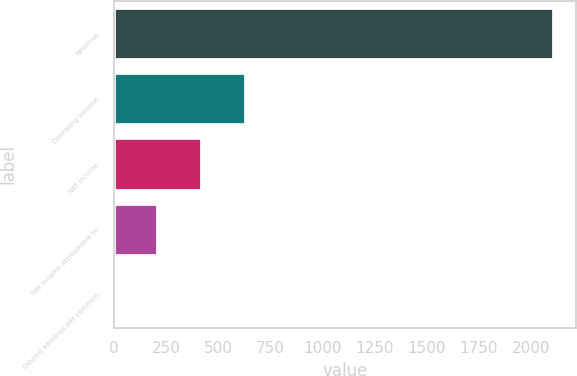<chart> <loc_0><loc_0><loc_500><loc_500><bar_chart><fcel>Revenue<fcel>Operating income<fcel>Net income<fcel>Net income attributable to<fcel>Diluted earnings per common<nl><fcel>2111.7<fcel>633.61<fcel>422.45<fcel>211.3<fcel>0.15<nl></chart> 